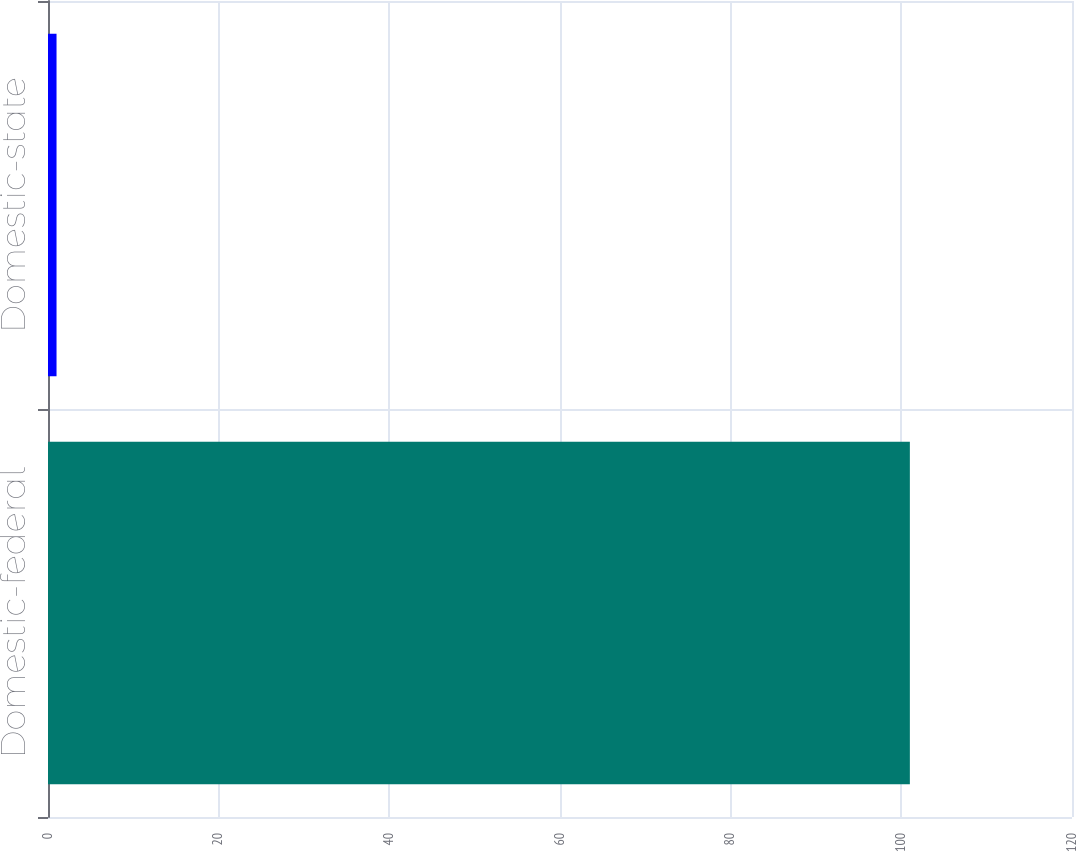<chart> <loc_0><loc_0><loc_500><loc_500><bar_chart><fcel>Domestic-federal<fcel>Domestic-state<nl><fcel>101<fcel>1<nl></chart> 